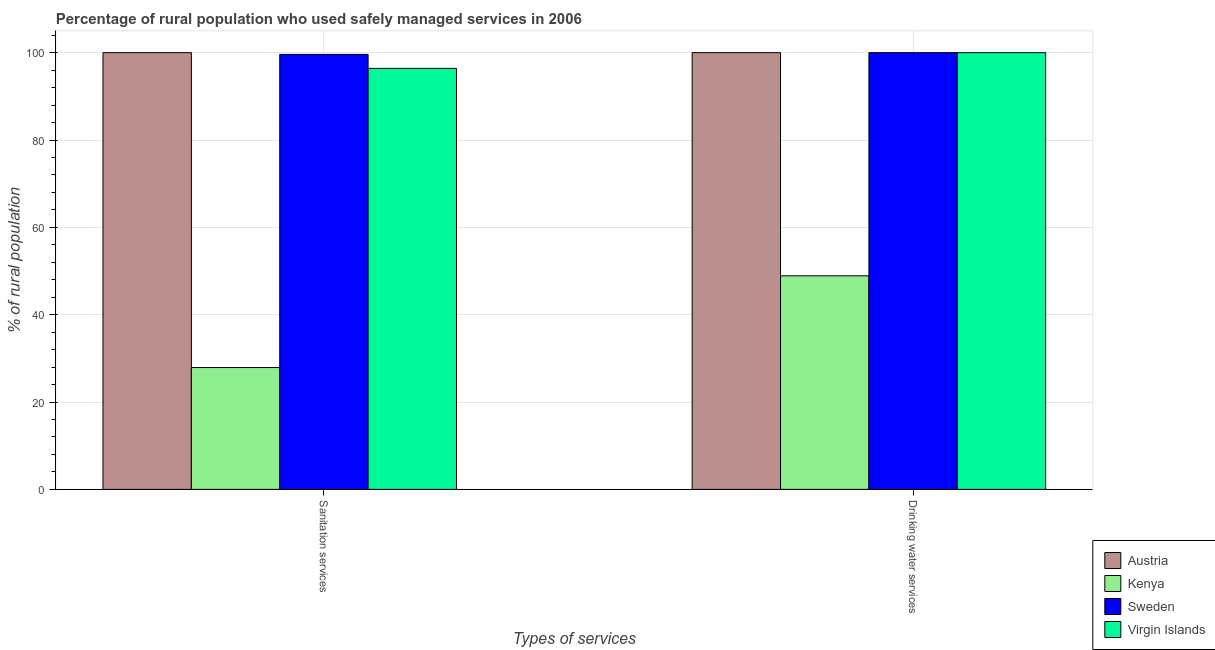How many groups of bars are there?
Keep it short and to the point. 2. Are the number of bars per tick equal to the number of legend labels?
Provide a succinct answer. Yes. Are the number of bars on each tick of the X-axis equal?
Keep it short and to the point. Yes. How many bars are there on the 1st tick from the left?
Keep it short and to the point. 4. How many bars are there on the 2nd tick from the right?
Provide a short and direct response. 4. What is the label of the 1st group of bars from the left?
Offer a very short reply. Sanitation services. What is the percentage of rural population who used sanitation services in Kenya?
Offer a very short reply. 27.9. Across all countries, what is the maximum percentage of rural population who used drinking water services?
Ensure brevity in your answer.  100. Across all countries, what is the minimum percentage of rural population who used drinking water services?
Provide a short and direct response. 48.9. In which country was the percentage of rural population who used drinking water services maximum?
Give a very brief answer. Austria. In which country was the percentage of rural population who used drinking water services minimum?
Your response must be concise. Kenya. What is the total percentage of rural population who used sanitation services in the graph?
Provide a succinct answer. 323.9. What is the difference between the percentage of rural population who used sanitation services in Sweden and the percentage of rural population who used drinking water services in Austria?
Ensure brevity in your answer.  -0.4. What is the average percentage of rural population who used sanitation services per country?
Provide a succinct answer. 80.97. What is the difference between the percentage of rural population who used drinking water services and percentage of rural population who used sanitation services in Virgin Islands?
Make the answer very short. 3.6. What is the ratio of the percentage of rural population who used sanitation services in Sweden to that in Kenya?
Offer a terse response. 3.57. Is the percentage of rural population who used drinking water services in Kenya less than that in Virgin Islands?
Give a very brief answer. Yes. In how many countries, is the percentage of rural population who used drinking water services greater than the average percentage of rural population who used drinking water services taken over all countries?
Your answer should be very brief. 3. What does the 3rd bar from the left in Drinking water services represents?
Make the answer very short. Sweden. What does the 3rd bar from the right in Drinking water services represents?
Provide a succinct answer. Kenya. How many bars are there?
Your answer should be very brief. 8. Does the graph contain any zero values?
Provide a succinct answer. No. Where does the legend appear in the graph?
Offer a very short reply. Bottom right. How are the legend labels stacked?
Your answer should be compact. Vertical. What is the title of the graph?
Your response must be concise. Percentage of rural population who used safely managed services in 2006. What is the label or title of the X-axis?
Make the answer very short. Types of services. What is the label or title of the Y-axis?
Make the answer very short. % of rural population. What is the % of rural population in Austria in Sanitation services?
Your answer should be compact. 100. What is the % of rural population in Kenya in Sanitation services?
Offer a very short reply. 27.9. What is the % of rural population of Sweden in Sanitation services?
Provide a succinct answer. 99.6. What is the % of rural population in Virgin Islands in Sanitation services?
Keep it short and to the point. 96.4. What is the % of rural population of Austria in Drinking water services?
Provide a short and direct response. 100. What is the % of rural population of Kenya in Drinking water services?
Make the answer very short. 48.9. What is the % of rural population of Sweden in Drinking water services?
Provide a succinct answer. 100. What is the % of rural population of Virgin Islands in Drinking water services?
Provide a short and direct response. 100. Across all Types of services, what is the maximum % of rural population in Austria?
Provide a succinct answer. 100. Across all Types of services, what is the maximum % of rural population of Kenya?
Provide a short and direct response. 48.9. Across all Types of services, what is the minimum % of rural population in Kenya?
Give a very brief answer. 27.9. Across all Types of services, what is the minimum % of rural population of Sweden?
Your answer should be very brief. 99.6. Across all Types of services, what is the minimum % of rural population of Virgin Islands?
Offer a terse response. 96.4. What is the total % of rural population of Austria in the graph?
Give a very brief answer. 200. What is the total % of rural population of Kenya in the graph?
Make the answer very short. 76.8. What is the total % of rural population of Sweden in the graph?
Offer a very short reply. 199.6. What is the total % of rural population of Virgin Islands in the graph?
Give a very brief answer. 196.4. What is the difference between the % of rural population of Austria in Sanitation services and that in Drinking water services?
Your answer should be very brief. 0. What is the difference between the % of rural population in Kenya in Sanitation services and that in Drinking water services?
Your answer should be very brief. -21. What is the difference between the % of rural population of Virgin Islands in Sanitation services and that in Drinking water services?
Keep it short and to the point. -3.6. What is the difference between the % of rural population in Austria in Sanitation services and the % of rural population in Kenya in Drinking water services?
Your answer should be very brief. 51.1. What is the difference between the % of rural population in Austria in Sanitation services and the % of rural population in Sweden in Drinking water services?
Your response must be concise. 0. What is the difference between the % of rural population in Kenya in Sanitation services and the % of rural population in Sweden in Drinking water services?
Give a very brief answer. -72.1. What is the difference between the % of rural population in Kenya in Sanitation services and the % of rural population in Virgin Islands in Drinking water services?
Keep it short and to the point. -72.1. What is the average % of rural population in Kenya per Types of services?
Offer a terse response. 38.4. What is the average % of rural population in Sweden per Types of services?
Your answer should be very brief. 99.8. What is the average % of rural population in Virgin Islands per Types of services?
Your answer should be compact. 98.2. What is the difference between the % of rural population of Austria and % of rural population of Kenya in Sanitation services?
Your answer should be very brief. 72.1. What is the difference between the % of rural population of Austria and % of rural population of Sweden in Sanitation services?
Offer a terse response. 0.4. What is the difference between the % of rural population in Austria and % of rural population in Virgin Islands in Sanitation services?
Your response must be concise. 3.6. What is the difference between the % of rural population of Kenya and % of rural population of Sweden in Sanitation services?
Offer a very short reply. -71.7. What is the difference between the % of rural population of Kenya and % of rural population of Virgin Islands in Sanitation services?
Provide a short and direct response. -68.5. What is the difference between the % of rural population of Austria and % of rural population of Kenya in Drinking water services?
Provide a short and direct response. 51.1. What is the difference between the % of rural population in Austria and % of rural population in Sweden in Drinking water services?
Your answer should be very brief. 0. What is the difference between the % of rural population of Austria and % of rural population of Virgin Islands in Drinking water services?
Make the answer very short. 0. What is the difference between the % of rural population of Kenya and % of rural population of Sweden in Drinking water services?
Your answer should be compact. -51.1. What is the difference between the % of rural population of Kenya and % of rural population of Virgin Islands in Drinking water services?
Your answer should be very brief. -51.1. What is the difference between the % of rural population of Sweden and % of rural population of Virgin Islands in Drinking water services?
Offer a terse response. 0. What is the ratio of the % of rural population in Kenya in Sanitation services to that in Drinking water services?
Your response must be concise. 0.57. What is the ratio of the % of rural population of Sweden in Sanitation services to that in Drinking water services?
Ensure brevity in your answer.  1. What is the difference between the highest and the second highest % of rural population of Sweden?
Your answer should be very brief. 0.4. What is the difference between the highest and the lowest % of rural population in Kenya?
Give a very brief answer. 21. What is the difference between the highest and the lowest % of rural population of Sweden?
Your response must be concise. 0.4. 